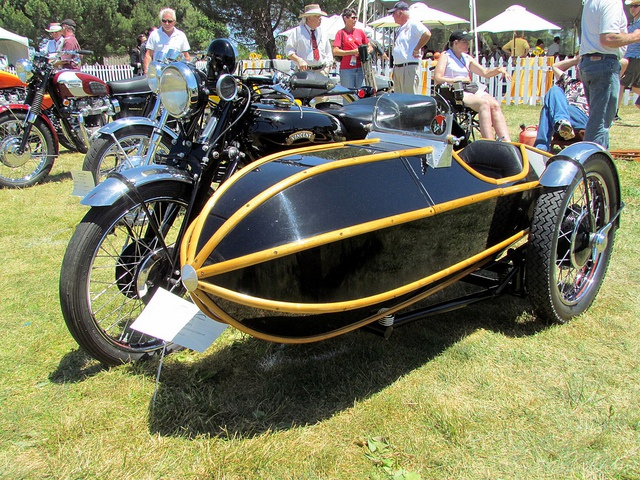Describe the objects in this image and their specific colors. I can see motorcycle in green, black, gray, white, and darkgray tones, motorcycle in green, black, gray, darkgray, and tan tones, people in green, darkblue, gray, darkgray, and white tones, motorcycle in green, black, gray, darkgray, and white tones, and people in green, white, tan, and gray tones in this image. 